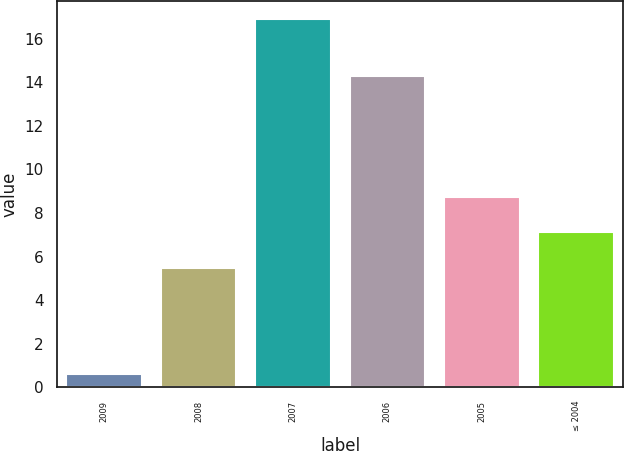Convert chart to OTSL. <chart><loc_0><loc_0><loc_500><loc_500><bar_chart><fcel>2009<fcel>2008<fcel>2007<fcel>2006<fcel>2005<fcel>≤ 2004<nl><fcel>0.6<fcel>5.5<fcel>16.9<fcel>14.3<fcel>8.76<fcel>7.13<nl></chart> 